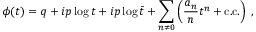Convert formula to latex. <formula><loc_0><loc_0><loc_500><loc_500>\phi ( t ) = q + i p \log { t } + i p \log { \bar { t } } + \sum _ { n \neq 0 } \left ( \frac { a _ { n } } { n } t ^ { n } + c . c . \right ) \, ,</formula> 